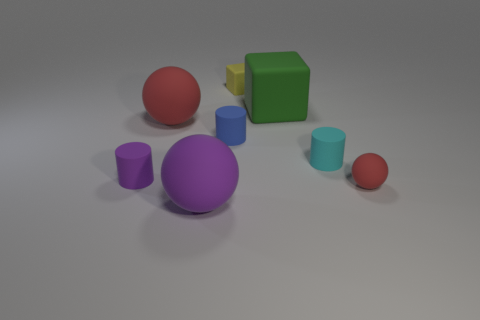Subtract all yellow cylinders. How many red spheres are left? 2 Subtract 1 cylinders. How many cylinders are left? 2 Subtract all red rubber balls. How many balls are left? 1 Add 1 small yellow things. How many objects exist? 9 Subtract all gray balls. Subtract all blue blocks. How many balls are left? 3 Subtract all cylinders. How many objects are left? 5 Add 4 big green rubber blocks. How many big green rubber blocks are left? 5 Add 5 brown shiny objects. How many brown shiny objects exist? 5 Subtract 1 blue cylinders. How many objects are left? 7 Subtract all tiny matte things. Subtract all large blocks. How many objects are left? 2 